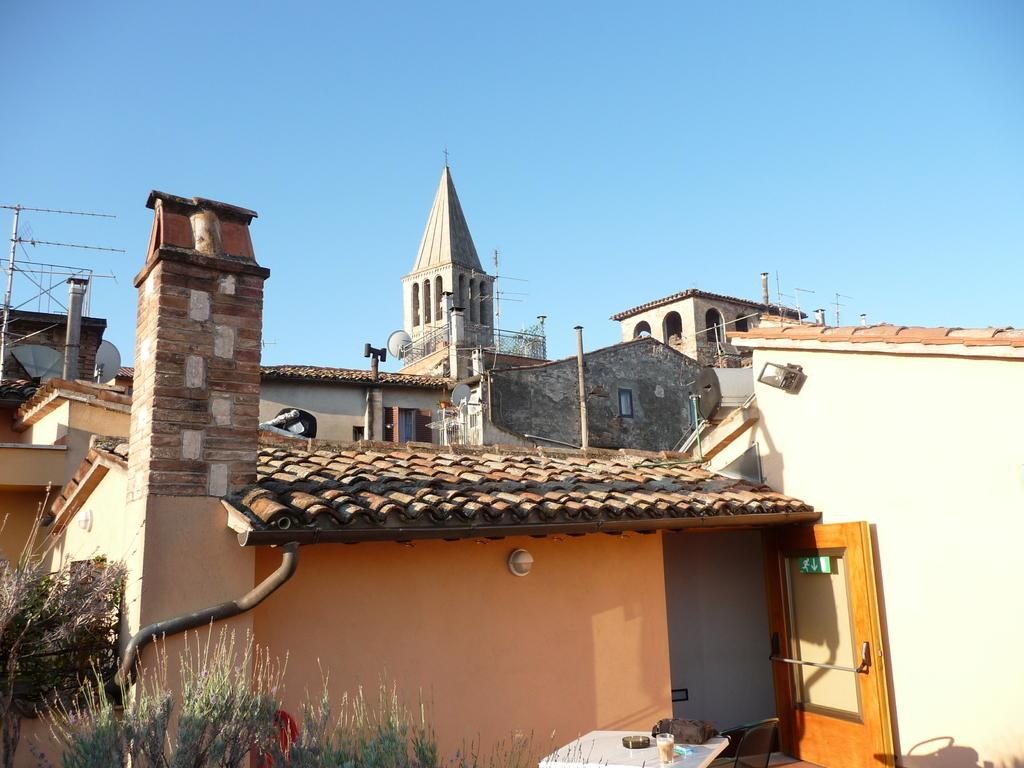What type of structures are present in the image? There are buildings in the image. What color is the sky in the image? The sky is blue in the image. How are the buildings being distributed in the image? The provided facts do not give information about the distribution of the buildings in the image. Are there any brothers present in the image? There is no information about any people, let alone brothers, in the image. 